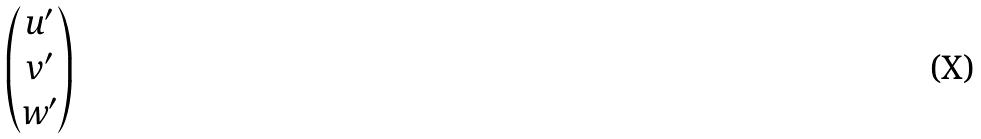<formula> <loc_0><loc_0><loc_500><loc_500>\begin{pmatrix} u ^ { \prime } \\ v ^ { \prime } \\ w ^ { \prime } \end{pmatrix}</formula> 